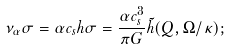Convert formula to latex. <formula><loc_0><loc_0><loc_500><loc_500>\nu _ { \alpha } \sigma = \alpha c _ { s } h \sigma = \frac { \alpha c _ { s } ^ { 3 } } { \pi G } \tilde { h } ( Q , \Omega / \kappa ) ;</formula> 